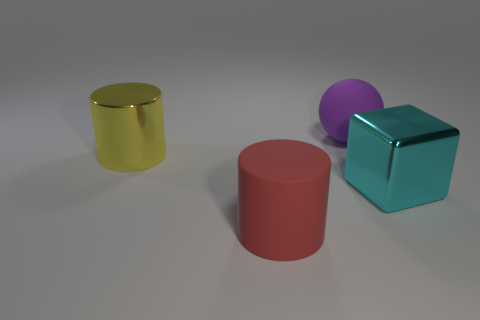Add 3 matte spheres. How many objects exist? 7 Subtract 1 cyan cubes. How many objects are left? 3 Subtract all large red things. Subtract all yellow metal cylinders. How many objects are left? 2 Add 3 big metallic objects. How many big metallic objects are left? 5 Add 2 small yellow metal spheres. How many small yellow metal spheres exist? 2 